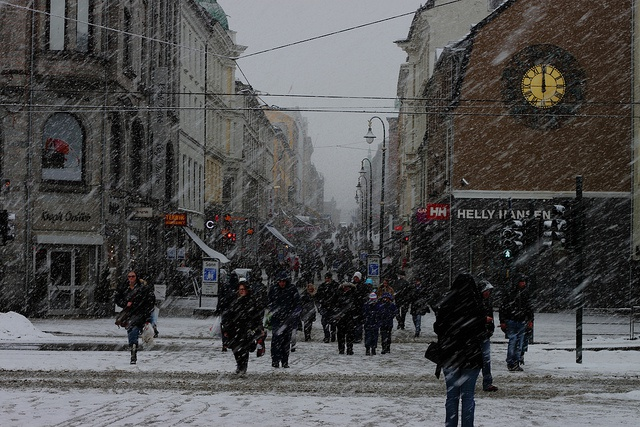Describe the objects in this image and their specific colors. I can see people in gray and black tones, people in gray, black, darkgray, and maroon tones, people in gray, black, maroon, and darkgray tones, people in gray, black, and darkgray tones, and people in gray, black, navy, and darkblue tones in this image. 